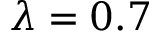<formula> <loc_0><loc_0><loc_500><loc_500>\lambda = 0 . 7</formula> 